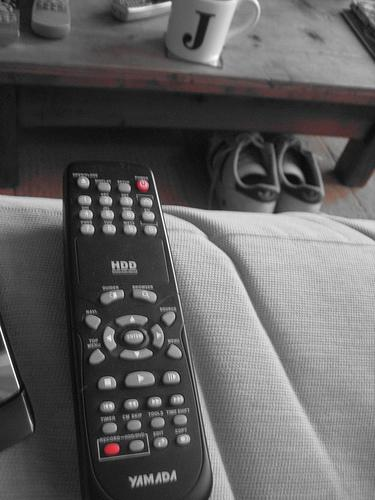Question: what color is the seat?
Choices:
A. Gray.
B. Red.
C. Blue.
D. Black.
Answer with the letter. Answer: A Question: what colors are on the remote?
Choices:
A. Yellow and blue.
B. Black, gray, red and white.
C. Red, yellow, blue, and green.
D. Black and red.
Answer with the letter. Answer: B Question: what is on the table?
Choices:
A. Magazines.
B. Food.
C. Remotes and a mug.
D. Remote and a tire.
Answer with the letter. Answer: C Question: how is the remote positioned?
Choices:
A. Facing up.
B. On the table.
C. On the floor.
D. Facing down.
Answer with the letter. Answer: A Question: what letter is on the mug?
Choices:
A. K.
B. L.
C. The letter J.
D. M.
Answer with the letter. Answer: C 